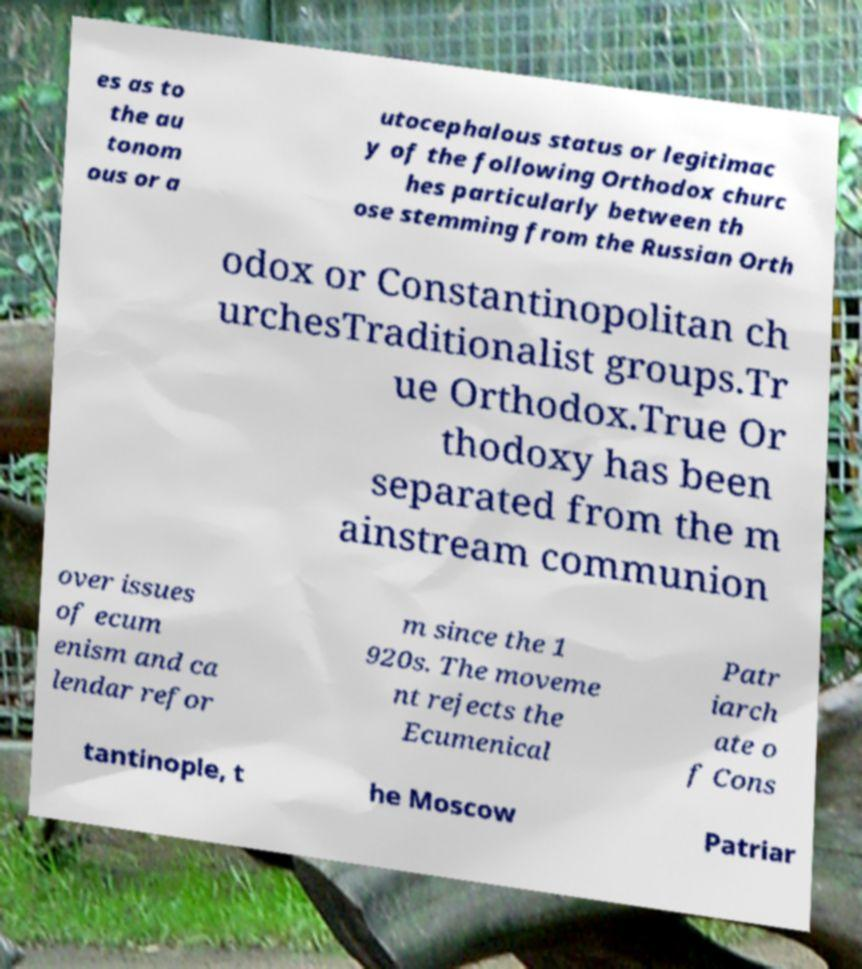Can you accurately transcribe the text from the provided image for me? es as to the au tonom ous or a utocephalous status or legitimac y of the following Orthodox churc hes particularly between th ose stemming from the Russian Orth odox or Constantinopolitan ch urchesTraditionalist groups.Tr ue Orthodox.True Or thodoxy has been separated from the m ainstream communion over issues of ecum enism and ca lendar refor m since the 1 920s. The moveme nt rejects the Ecumenical Patr iarch ate o f Cons tantinople, t he Moscow Patriar 